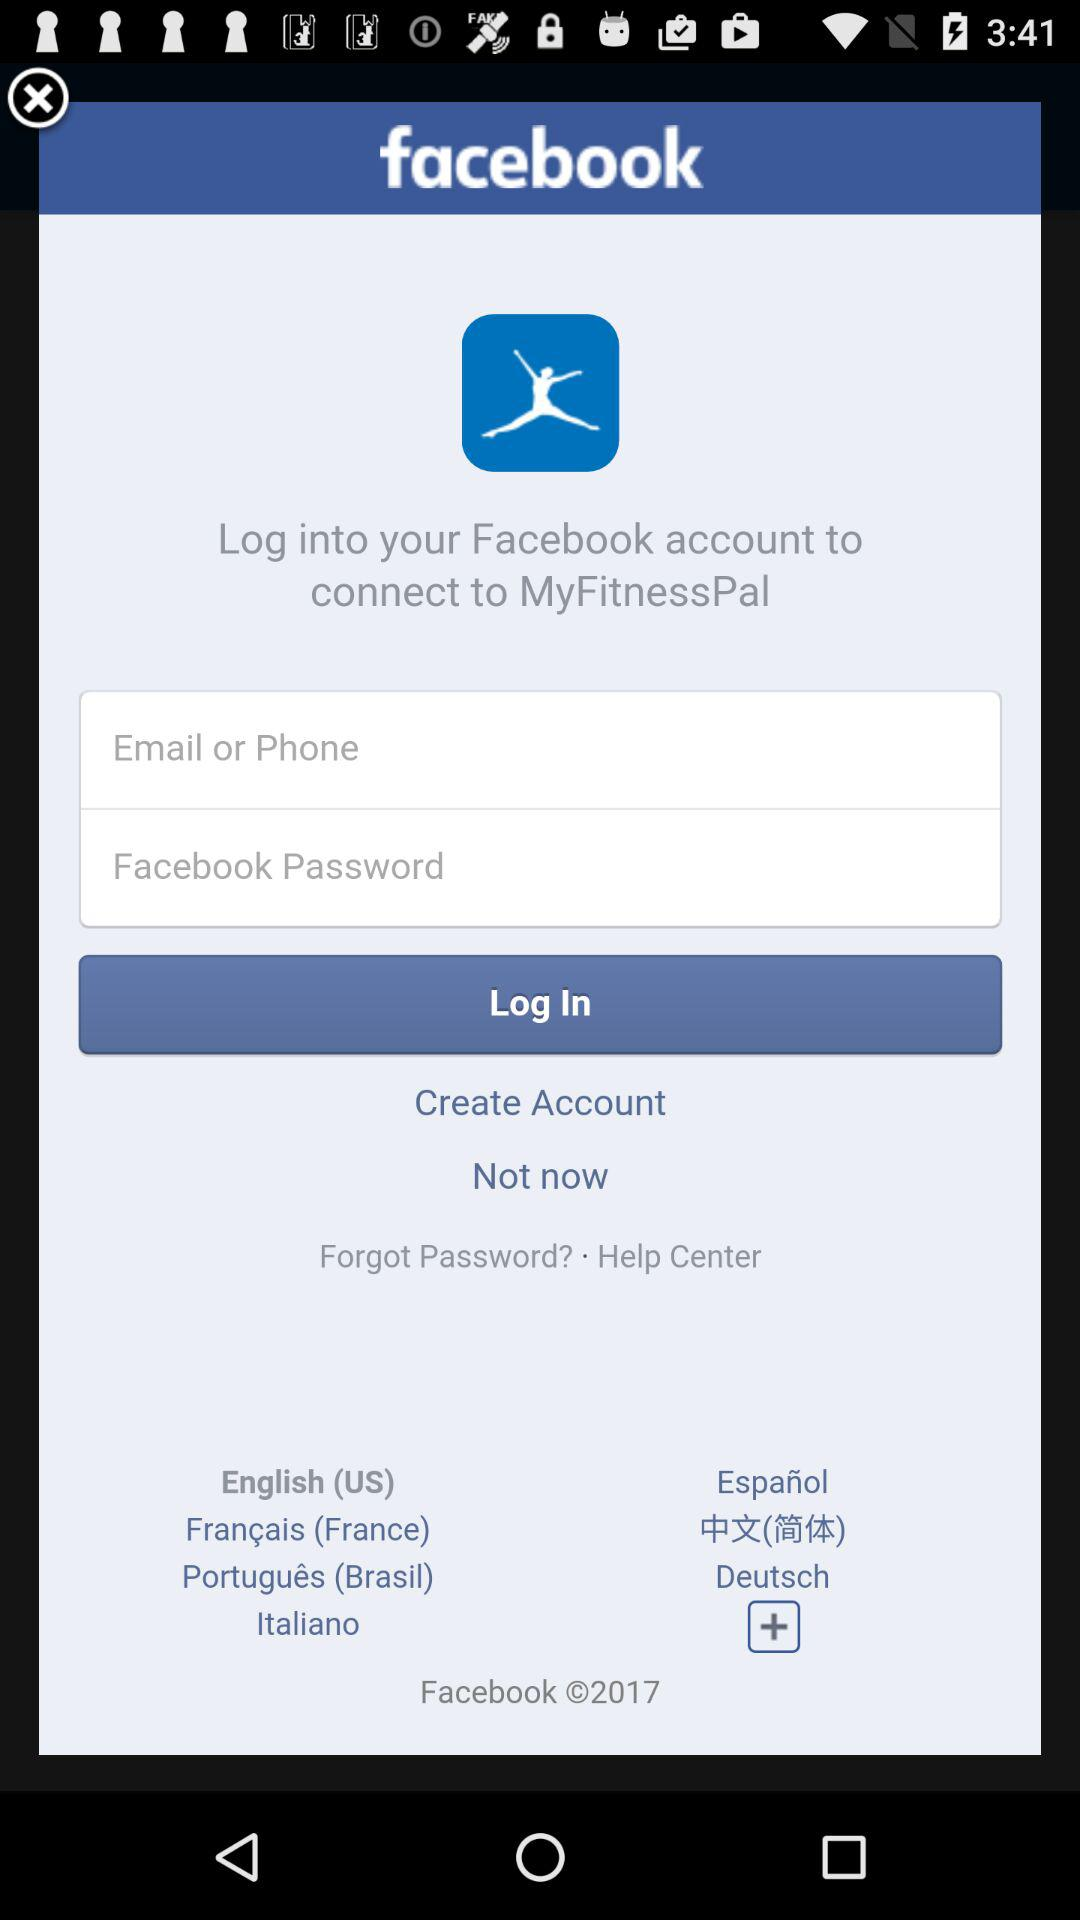Where can we login to connect to MyFitnessPal? We can login to "Facebook" and connect to MyFitnessPal. 